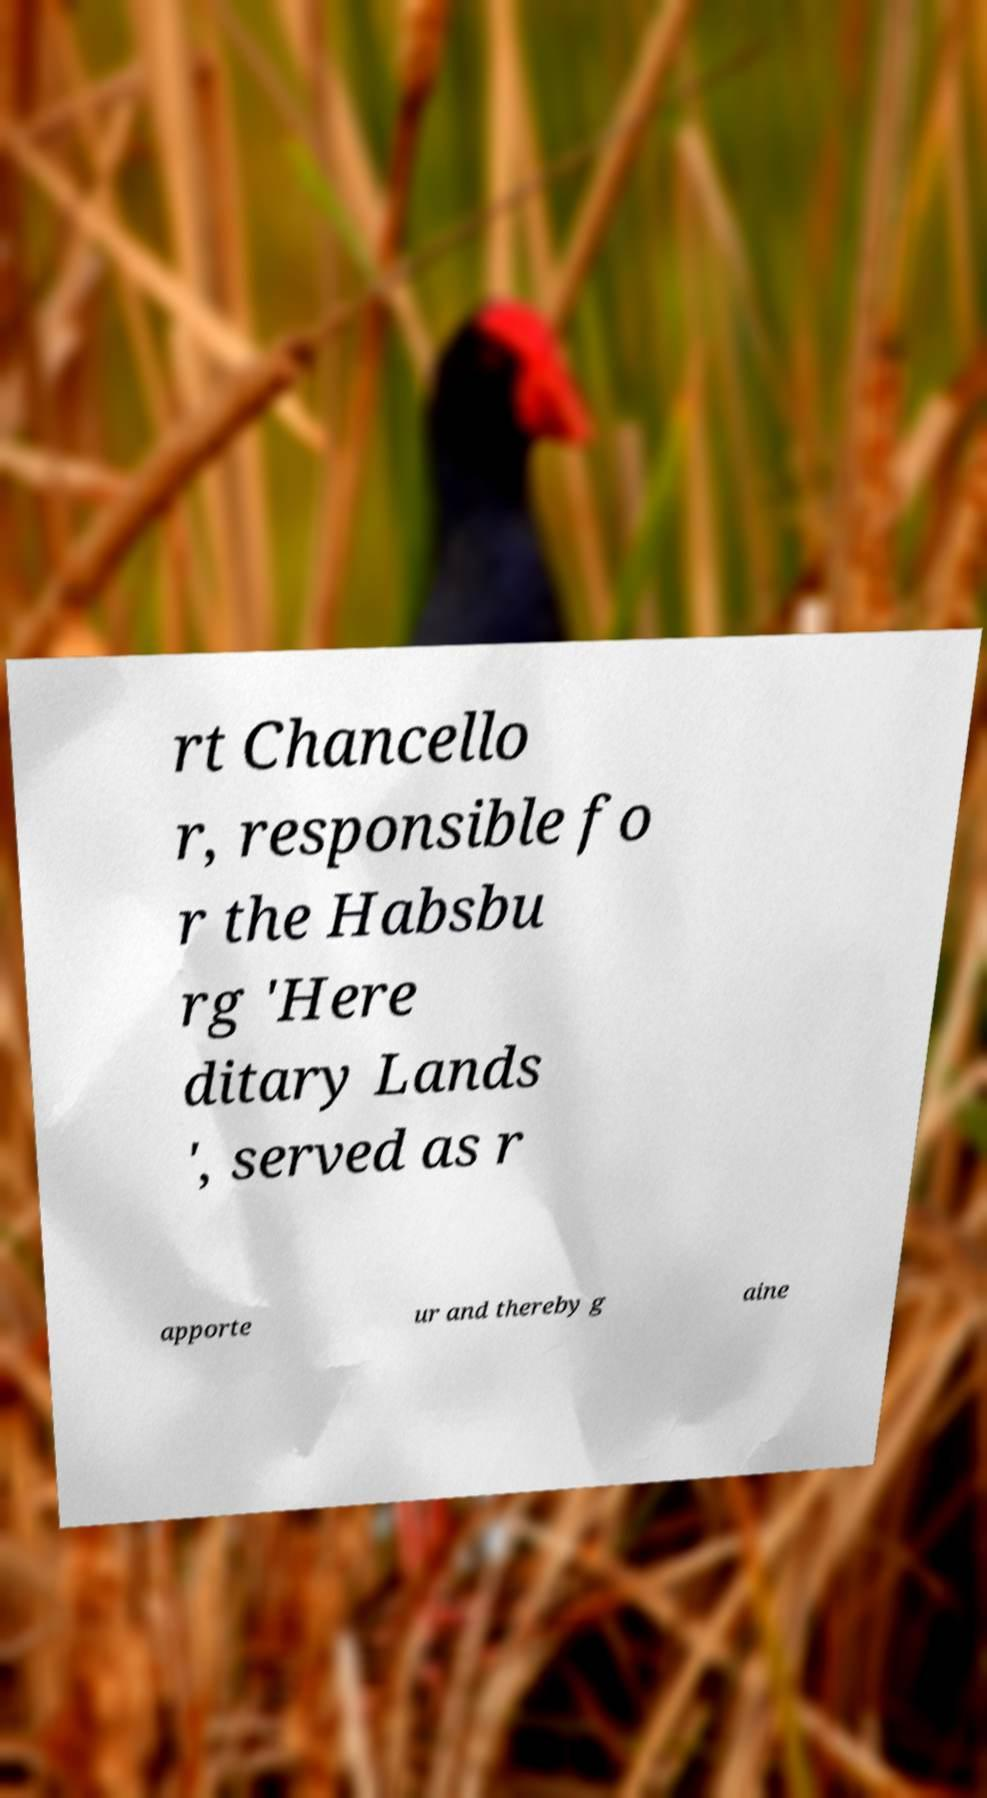Could you extract and type out the text from this image? rt Chancello r, responsible fo r the Habsbu rg 'Here ditary Lands ', served as r apporte ur and thereby g aine 